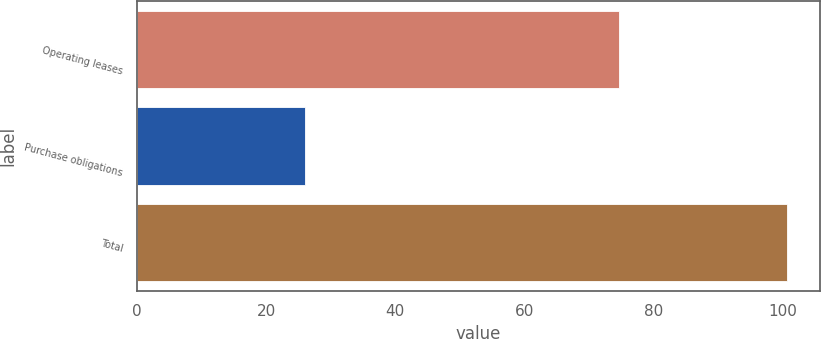<chart> <loc_0><loc_0><loc_500><loc_500><bar_chart><fcel>Operating leases<fcel>Purchase obligations<fcel>Total<nl><fcel>74.7<fcel>26<fcel>100.7<nl></chart> 